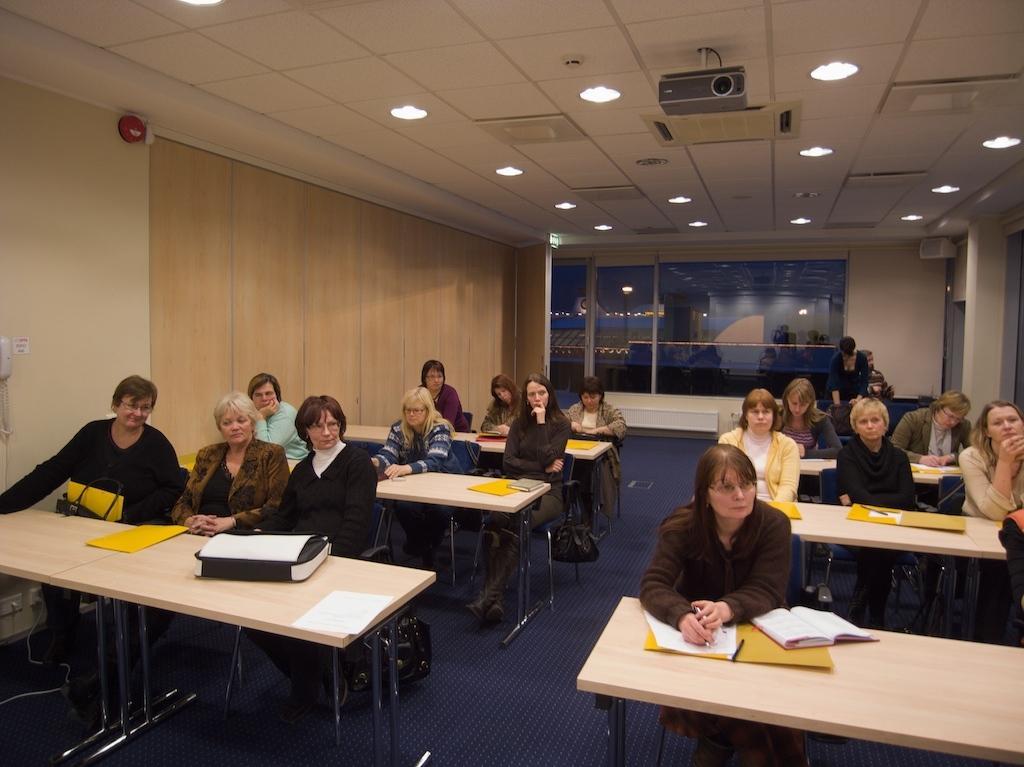Can you describe this image briefly? In this picture we can see a group of people sitting on chairs and in front of them there is table and on table we can see files, papers, book, pen, bag and in background we can see glass window, projector, lights, wall. 